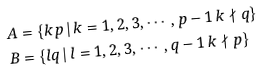<formula> <loc_0><loc_0><loc_500><loc_500>A & = \{ k p \, | \, k = 1 , 2 , 3 , \cdots , p - 1 \, k \nmid q \} \\ B & = \{ l q \, | \, l = 1 , 2 , 3 , \cdots , q - 1 \, k \nmid p \}</formula> 